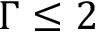Convert formula to latex. <formula><loc_0><loc_0><loc_500><loc_500>\Gamma \leq 2</formula> 